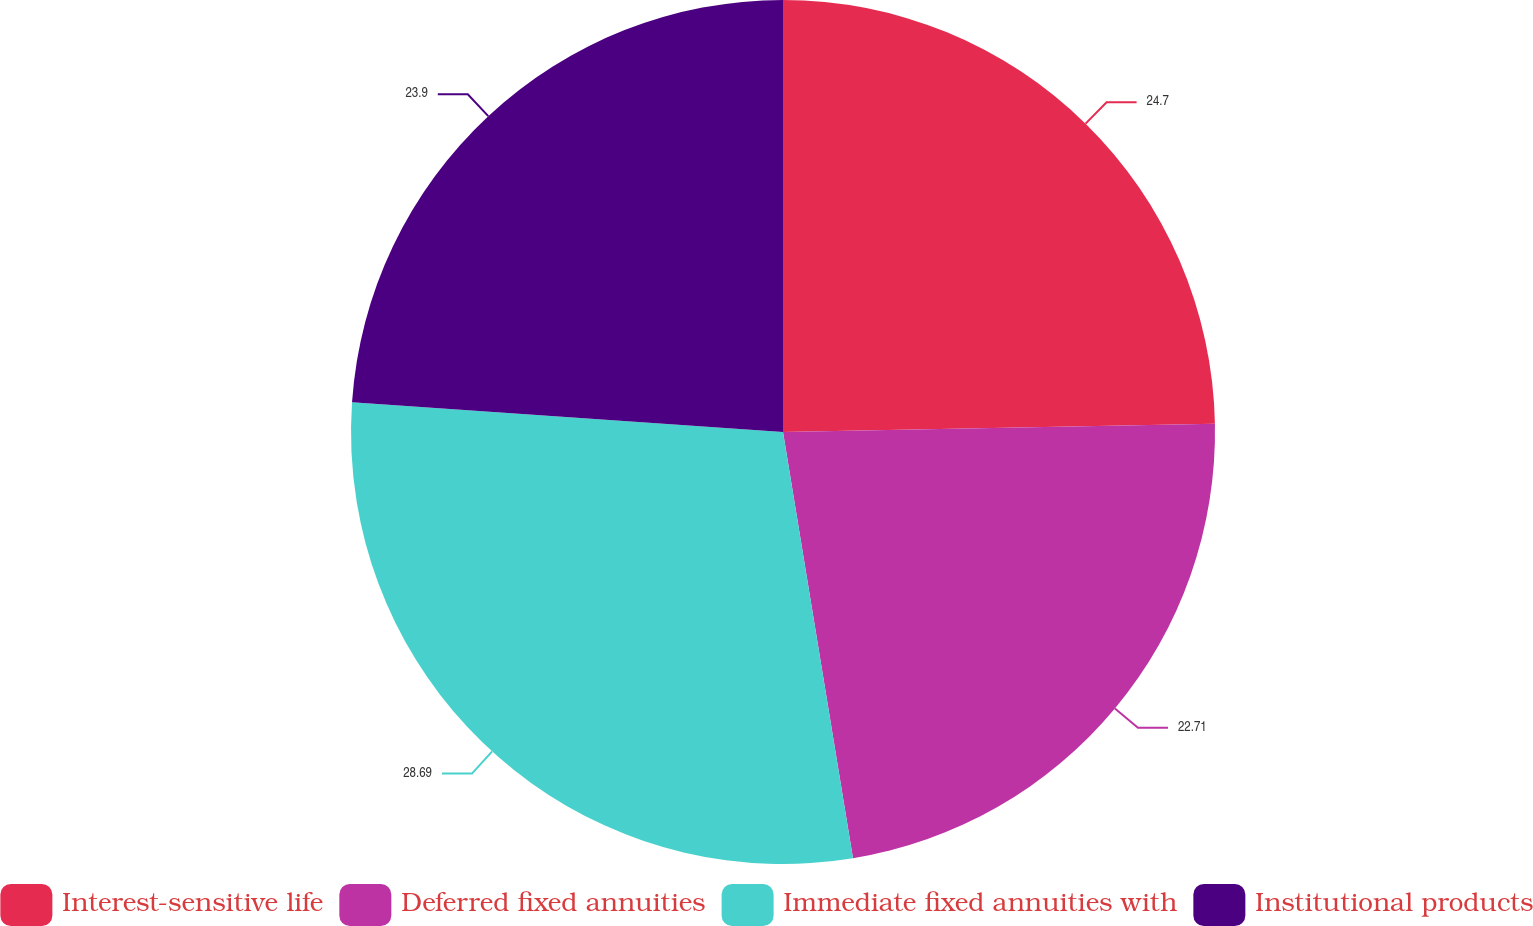Convert chart to OTSL. <chart><loc_0><loc_0><loc_500><loc_500><pie_chart><fcel>Interest-sensitive life<fcel>Deferred fixed annuities<fcel>Immediate fixed annuities with<fcel>Institutional products<nl><fcel>24.7%<fcel>22.71%<fcel>28.69%<fcel>23.9%<nl></chart> 